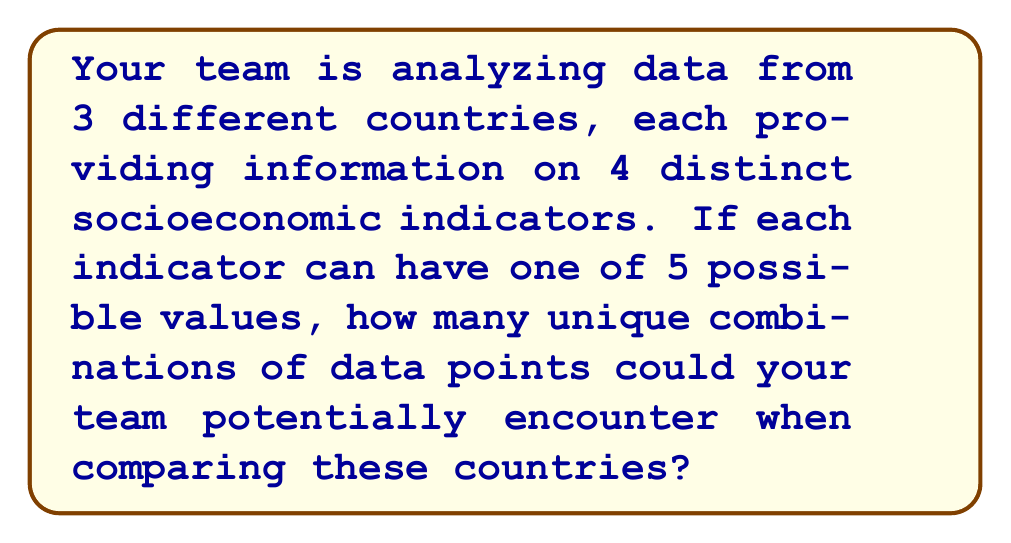Show me your answer to this math problem. Let's approach this step-by-step:

1) We have 3 countries, each providing data on 4 indicators.

2) Each indicator can have 5 possible values.

3) For each country, we need to calculate the number of possible combinations for its 4 indicators:
   - This is a case of independent choices, so we multiply:
   $$5 \times 5 \times 5 \times 5 = 5^4 = 625$$

4) Now, we have 625 possible combinations for each country.

5) To find the total number of unique combinations across all three countries, we again use the multiplication principle:
   $$625 \times 625 \times 625 = 625^3 = 5^{12}$$

6) Calculate the final result:
   $$5^{12} = 244,140,625$$

Therefore, there are 244,140,625 unique combinations of data points that your team could potentially encounter when comparing these three countries.
Answer: $5^{12} = 244,140,625$ 